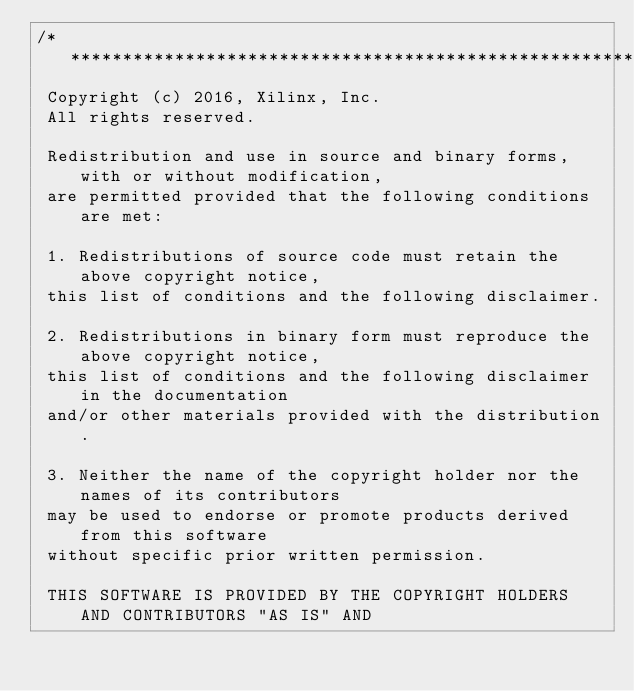Convert code to text. <code><loc_0><loc_0><loc_500><loc_500><_C++_>/***************************************************************************
 Copyright (c) 2016, Xilinx, Inc.
 All rights reserved.

 Redistribution and use in source and binary forms, with or without modification,
 are permitted provided that the following conditions are met:

 1. Redistributions of source code must retain the above copyright notice,
 this list of conditions and the following disclaimer.

 2. Redistributions in binary form must reproduce the above copyright notice,
 this list of conditions and the following disclaimer in the documentation
 and/or other materials provided with the distribution.

 3. Neither the name of the copyright holder nor the names of its contributors
 may be used to endorse or promote products derived from this software
 without specific prior written permission.

 THIS SOFTWARE IS PROVIDED BY THE COPYRIGHT HOLDERS AND CONTRIBUTORS "AS IS" AND</code> 